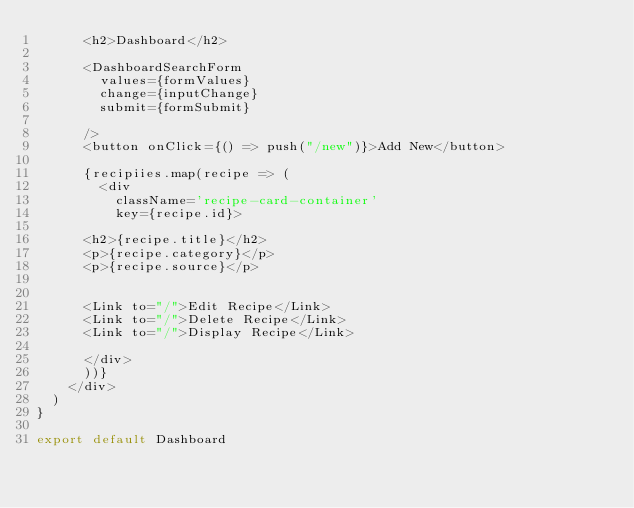<code> <loc_0><loc_0><loc_500><loc_500><_JavaScript_>      <h2>Dashboard</h2>

      <DashboardSearchForm
        values={formValues}
        change={inputChange}
        submit={formSubmit}

      />
      <button onClick={() => push("/new")}>Add New</button>

      {recipiies.map(recipe => (
        <div 
          className='recipe-card-container'
          key={recipe.id}>

      <h2>{recipe.title}</h2>
      <p>{recipe.category}</p>
      <p>{recipe.source}</p>


      <Link to="/">Edit Recipe</Link>
      <Link to="/">Delete Recipe</Link>
      <Link to="/">Display Recipe</Link>

      </div>
      ))}
    </div>
  )
}

export default Dashboard
	</code> 